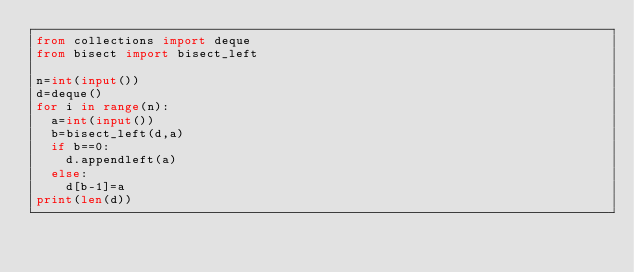Convert code to text. <code><loc_0><loc_0><loc_500><loc_500><_Python_>from collections import deque
from bisect import bisect_left

n=int(input())
d=deque()
for i in range(n):
  a=int(input())
  b=bisect_left(d,a)
  if b==0:
    d.appendleft(a)
  else:
    d[b-1]=a 
print(len(d))
</code> 